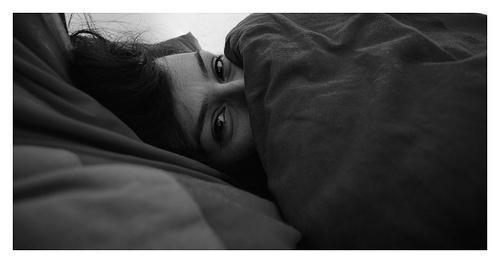How many people are there?
Give a very brief answer. 1. How many people are swimming in the image?
Give a very brief answer. 0. 